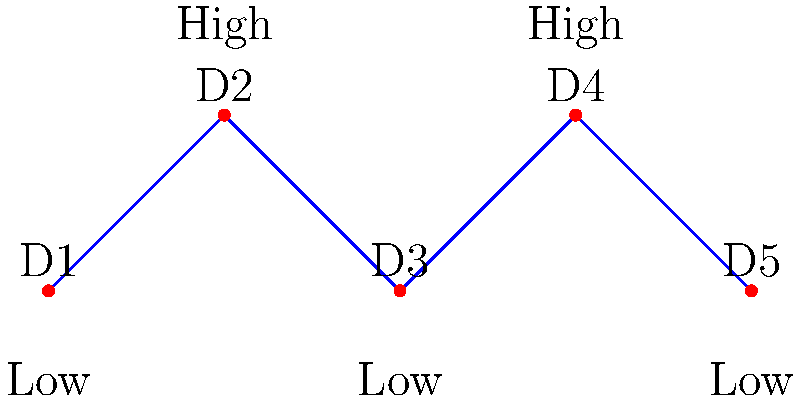In the diagram, school districts (D1 to D5) are represented as nodes, with connections indicating geographical adjacency. The vertical position of each node represents the average income level (high or low) in that district. What is the minimum number of connections that need to be removed to isolate all low-income districts from high-income districts? To solve this problem, we need to follow these steps:

1. Identify the low-income and high-income districts:
   - Low-income: D1, D3, D5
   - High-income: D2, D4

2. Examine the connections between low-income and high-income districts:
   - D1 is connected to D2
   - D2 is connected to D3
   - D3 is connected to D4
   - D4 is connected to D5

3. Count the number of connections between districts of different income levels:
   - D1--D2
   - D2--D3
   - D3--D4
   - D4--D5

4. Determine the minimum number of connections to remove:
   To isolate all low-income districts from high-income districts, we need to remove all connections between districts of different income levels. In this case, that means removing all 4 connections identified in step 3.

Therefore, the minimum number of connections that need to be removed to isolate all low-income districts from high-income districts is 4.
Answer: 4 